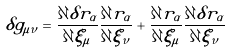<formula> <loc_0><loc_0><loc_500><loc_500>\delta g _ { \mu \nu } = \frac { \partial \delta r _ { \alpha } } { \partial \xi _ { \mu } } \frac { \partial r _ { \alpha } } { \partial \xi _ { \nu } } + \frac { \partial r _ { \alpha } } { \partial \xi _ { \mu } } \frac { \partial \delta r _ { \alpha } } { \partial \xi _ { \nu } }</formula> 